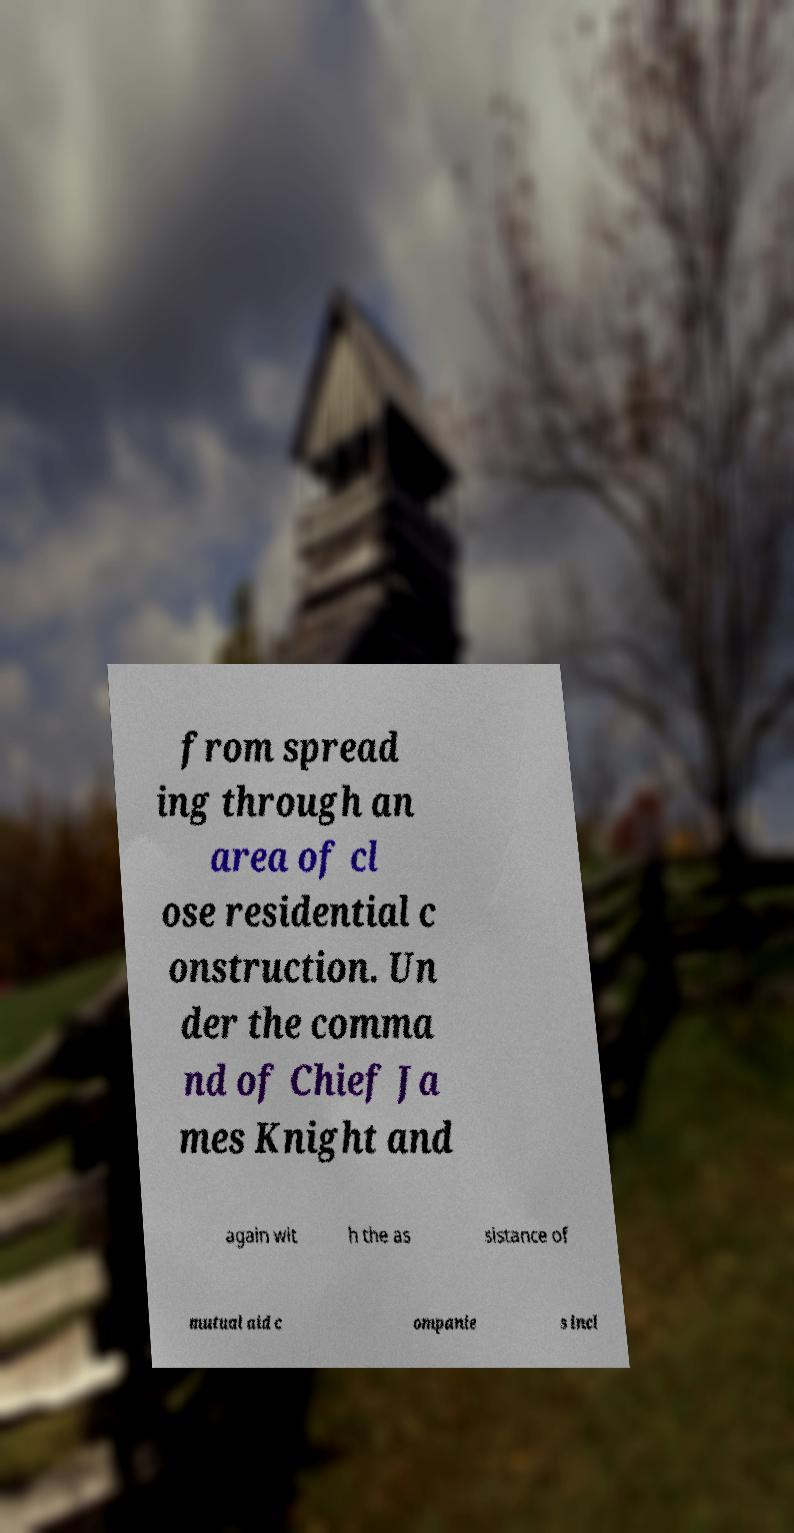Can you accurately transcribe the text from the provided image for me? from spread ing through an area of cl ose residential c onstruction. Un der the comma nd of Chief Ja mes Knight and again wit h the as sistance of mutual aid c ompanie s incl 